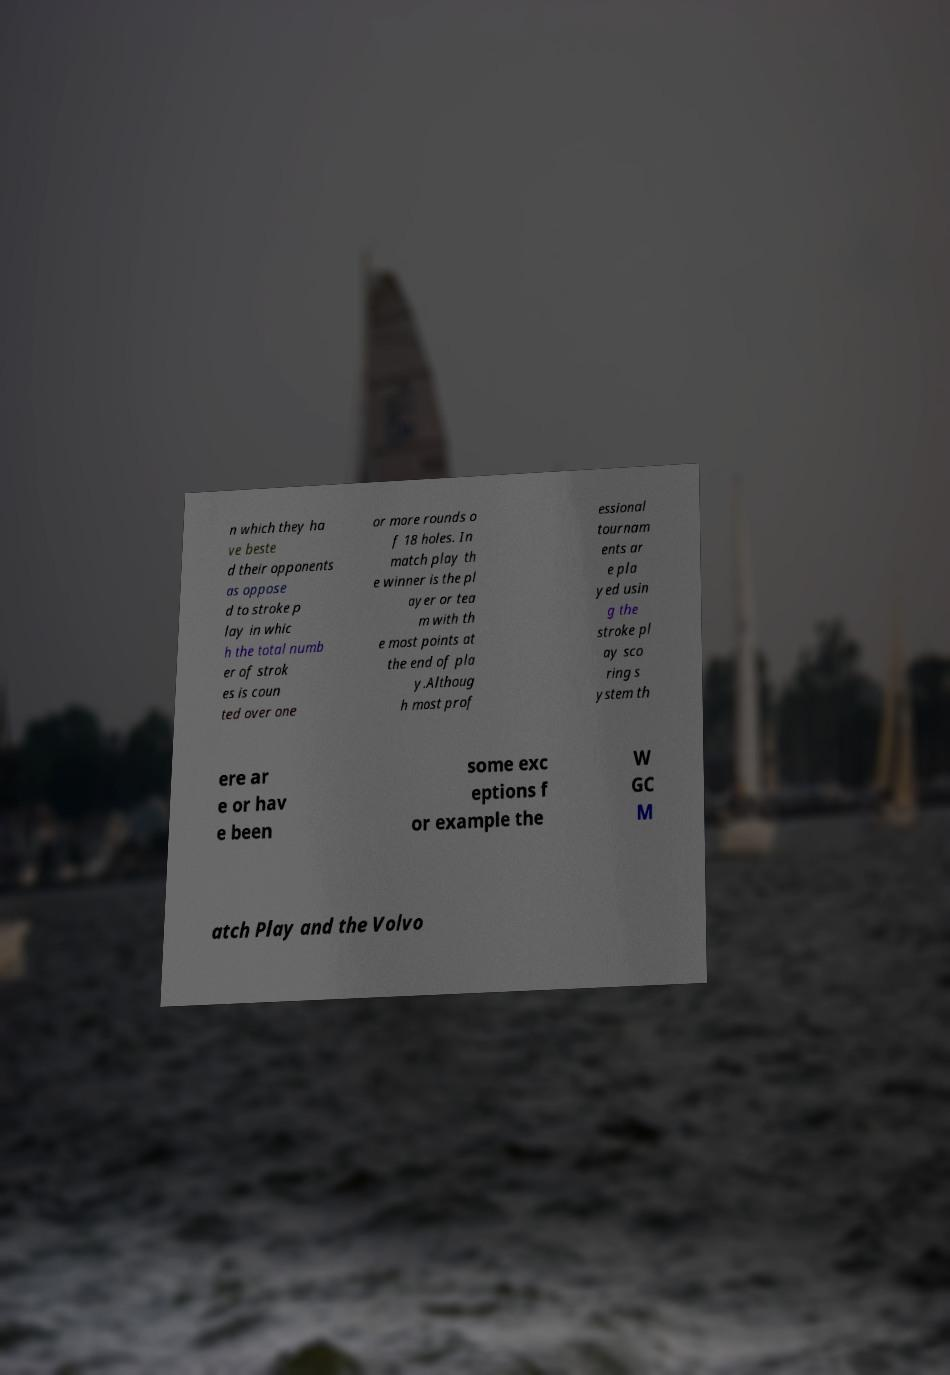Please read and relay the text visible in this image. What does it say? n which they ha ve beste d their opponents as oppose d to stroke p lay in whic h the total numb er of strok es is coun ted over one or more rounds o f 18 holes. In match play th e winner is the pl ayer or tea m with th e most points at the end of pla y.Althoug h most prof essional tournam ents ar e pla yed usin g the stroke pl ay sco ring s ystem th ere ar e or hav e been some exc eptions f or example the W GC M atch Play and the Volvo 